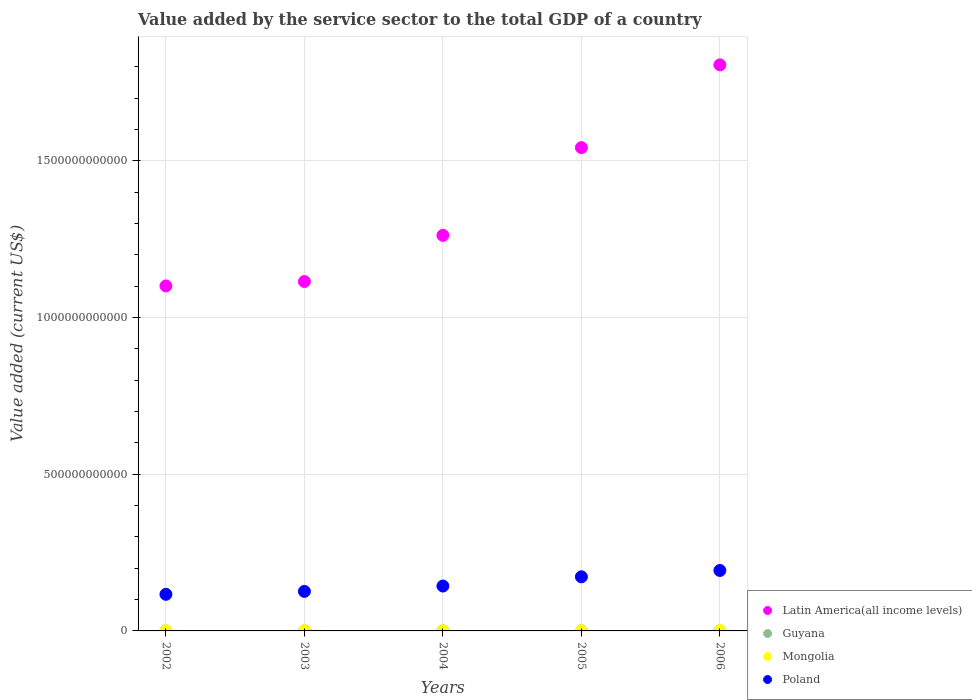Is the number of dotlines equal to the number of legend labels?
Offer a terse response. Yes. What is the value added by the service sector to the total GDP in Guyana in 2005?
Your answer should be compact. 3.13e+08. Across all years, what is the maximum value added by the service sector to the total GDP in Poland?
Provide a short and direct response. 1.93e+11. Across all years, what is the minimum value added by the service sector to the total GDP in Mongolia?
Ensure brevity in your answer.  6.51e+08. In which year was the value added by the service sector to the total GDP in Guyana maximum?
Keep it short and to the point. 2006. In which year was the value added by the service sector to the total GDP in Latin America(all income levels) minimum?
Your answer should be very brief. 2002. What is the total value added by the service sector to the total GDP in Guyana in the graph?
Offer a terse response. 1.71e+09. What is the difference between the value added by the service sector to the total GDP in Guyana in 2003 and that in 2005?
Provide a succinct answer. -4.98e+07. What is the difference between the value added by the service sector to the total GDP in Mongolia in 2006 and the value added by the service sector to the total GDP in Guyana in 2003?
Ensure brevity in your answer.  8.84e+08. What is the average value added by the service sector to the total GDP in Mongolia per year?
Ensure brevity in your answer.  8.53e+08. In the year 2002, what is the difference between the value added by the service sector to the total GDP in Guyana and value added by the service sector to the total GDP in Latin America(all income levels)?
Provide a short and direct response. -1.10e+12. What is the ratio of the value added by the service sector to the total GDP in Latin America(all income levels) in 2004 to that in 2005?
Provide a succinct answer. 0.82. Is the value added by the service sector to the total GDP in Poland in 2002 less than that in 2006?
Offer a very short reply. Yes. Is the difference between the value added by the service sector to the total GDP in Guyana in 2003 and 2006 greater than the difference between the value added by the service sector to the total GDP in Latin America(all income levels) in 2003 and 2006?
Your response must be concise. Yes. What is the difference between the highest and the second highest value added by the service sector to the total GDP in Latin America(all income levels)?
Give a very brief answer. 2.64e+11. What is the difference between the highest and the lowest value added by the service sector to the total GDP in Guyana?
Provide a succinct answer. 3.55e+08. Is it the case that in every year, the sum of the value added by the service sector to the total GDP in Mongolia and value added by the service sector to the total GDP in Guyana  is greater than the sum of value added by the service sector to the total GDP in Latin America(all income levels) and value added by the service sector to the total GDP in Poland?
Offer a very short reply. No. Is it the case that in every year, the sum of the value added by the service sector to the total GDP in Mongolia and value added by the service sector to the total GDP in Poland  is greater than the value added by the service sector to the total GDP in Latin America(all income levels)?
Keep it short and to the point. No. Does the value added by the service sector to the total GDP in Guyana monotonically increase over the years?
Provide a short and direct response. Yes. Is the value added by the service sector to the total GDP in Guyana strictly greater than the value added by the service sector to the total GDP in Mongolia over the years?
Give a very brief answer. No. How many years are there in the graph?
Keep it short and to the point. 5. What is the difference between two consecutive major ticks on the Y-axis?
Your response must be concise. 5.00e+11. Does the graph contain any zero values?
Make the answer very short. No. Where does the legend appear in the graph?
Your answer should be very brief. Bottom right. How many legend labels are there?
Offer a very short reply. 4. What is the title of the graph?
Keep it short and to the point. Value added by the service sector to the total GDP of a country. What is the label or title of the X-axis?
Provide a succinct answer. Years. What is the label or title of the Y-axis?
Your response must be concise. Value added (current US$). What is the Value added (current US$) of Latin America(all income levels) in 2002?
Your answer should be very brief. 1.10e+12. What is the Value added (current US$) in Guyana in 2002?
Provide a succinct answer. 2.51e+08. What is the Value added (current US$) in Mongolia in 2002?
Your response must be concise. 6.51e+08. What is the Value added (current US$) of Poland in 2002?
Provide a succinct answer. 1.17e+11. What is the Value added (current US$) of Latin America(all income levels) in 2003?
Provide a succinct answer. 1.11e+12. What is the Value added (current US$) in Guyana in 2003?
Make the answer very short. 2.63e+08. What is the Value added (current US$) of Mongolia in 2003?
Offer a very short reply. 7.20e+08. What is the Value added (current US$) of Poland in 2003?
Provide a succinct answer. 1.26e+11. What is the Value added (current US$) in Latin America(all income levels) in 2004?
Offer a terse response. 1.26e+12. What is the Value added (current US$) in Guyana in 2004?
Make the answer very short. 2.75e+08. What is the Value added (current US$) of Mongolia in 2004?
Offer a very short reply. 8.02e+08. What is the Value added (current US$) in Poland in 2004?
Make the answer very short. 1.43e+11. What is the Value added (current US$) of Latin America(all income levels) in 2005?
Your answer should be very brief. 1.54e+12. What is the Value added (current US$) of Guyana in 2005?
Keep it short and to the point. 3.13e+08. What is the Value added (current US$) in Mongolia in 2005?
Provide a short and direct response. 9.45e+08. What is the Value added (current US$) in Poland in 2005?
Your response must be concise. 1.73e+11. What is the Value added (current US$) in Latin America(all income levels) in 2006?
Make the answer very short. 1.81e+12. What is the Value added (current US$) of Guyana in 2006?
Ensure brevity in your answer.  6.05e+08. What is the Value added (current US$) in Mongolia in 2006?
Give a very brief answer. 1.15e+09. What is the Value added (current US$) of Poland in 2006?
Your response must be concise. 1.93e+11. Across all years, what is the maximum Value added (current US$) in Latin America(all income levels)?
Provide a succinct answer. 1.81e+12. Across all years, what is the maximum Value added (current US$) of Guyana?
Your answer should be compact. 6.05e+08. Across all years, what is the maximum Value added (current US$) in Mongolia?
Offer a very short reply. 1.15e+09. Across all years, what is the maximum Value added (current US$) in Poland?
Provide a short and direct response. 1.93e+11. Across all years, what is the minimum Value added (current US$) of Latin America(all income levels)?
Offer a very short reply. 1.10e+12. Across all years, what is the minimum Value added (current US$) in Guyana?
Offer a terse response. 2.51e+08. Across all years, what is the minimum Value added (current US$) in Mongolia?
Give a very brief answer. 6.51e+08. Across all years, what is the minimum Value added (current US$) of Poland?
Provide a short and direct response. 1.17e+11. What is the total Value added (current US$) of Latin America(all income levels) in the graph?
Provide a short and direct response. 6.83e+12. What is the total Value added (current US$) in Guyana in the graph?
Make the answer very short. 1.71e+09. What is the total Value added (current US$) of Mongolia in the graph?
Your answer should be very brief. 4.26e+09. What is the total Value added (current US$) in Poland in the graph?
Make the answer very short. 7.52e+11. What is the difference between the Value added (current US$) of Latin America(all income levels) in 2002 and that in 2003?
Give a very brief answer. -1.41e+1. What is the difference between the Value added (current US$) in Guyana in 2002 and that in 2003?
Give a very brief answer. -1.23e+07. What is the difference between the Value added (current US$) in Mongolia in 2002 and that in 2003?
Provide a short and direct response. -6.96e+07. What is the difference between the Value added (current US$) of Poland in 2002 and that in 2003?
Your answer should be very brief. -9.34e+09. What is the difference between the Value added (current US$) in Latin America(all income levels) in 2002 and that in 2004?
Your answer should be very brief. -1.61e+11. What is the difference between the Value added (current US$) in Guyana in 2002 and that in 2004?
Keep it short and to the point. -2.39e+07. What is the difference between the Value added (current US$) of Mongolia in 2002 and that in 2004?
Provide a short and direct response. -1.51e+08. What is the difference between the Value added (current US$) in Poland in 2002 and that in 2004?
Ensure brevity in your answer.  -2.64e+1. What is the difference between the Value added (current US$) of Latin America(all income levels) in 2002 and that in 2005?
Provide a short and direct response. -4.41e+11. What is the difference between the Value added (current US$) of Guyana in 2002 and that in 2005?
Your response must be concise. -6.21e+07. What is the difference between the Value added (current US$) of Mongolia in 2002 and that in 2005?
Provide a short and direct response. -2.94e+08. What is the difference between the Value added (current US$) in Poland in 2002 and that in 2005?
Provide a succinct answer. -5.59e+1. What is the difference between the Value added (current US$) of Latin America(all income levels) in 2002 and that in 2006?
Provide a succinct answer. -7.05e+11. What is the difference between the Value added (current US$) of Guyana in 2002 and that in 2006?
Provide a succinct answer. -3.55e+08. What is the difference between the Value added (current US$) in Mongolia in 2002 and that in 2006?
Offer a very short reply. -4.96e+08. What is the difference between the Value added (current US$) in Poland in 2002 and that in 2006?
Provide a succinct answer. -7.61e+1. What is the difference between the Value added (current US$) of Latin America(all income levels) in 2003 and that in 2004?
Keep it short and to the point. -1.47e+11. What is the difference between the Value added (current US$) in Guyana in 2003 and that in 2004?
Offer a very short reply. -1.16e+07. What is the difference between the Value added (current US$) in Mongolia in 2003 and that in 2004?
Give a very brief answer. -8.12e+07. What is the difference between the Value added (current US$) of Poland in 2003 and that in 2004?
Make the answer very short. -1.71e+1. What is the difference between the Value added (current US$) in Latin America(all income levels) in 2003 and that in 2005?
Keep it short and to the point. -4.27e+11. What is the difference between the Value added (current US$) in Guyana in 2003 and that in 2005?
Keep it short and to the point. -4.98e+07. What is the difference between the Value added (current US$) of Mongolia in 2003 and that in 2005?
Offer a very short reply. -2.25e+08. What is the difference between the Value added (current US$) of Poland in 2003 and that in 2005?
Offer a terse response. -4.66e+1. What is the difference between the Value added (current US$) of Latin America(all income levels) in 2003 and that in 2006?
Your answer should be compact. -6.91e+11. What is the difference between the Value added (current US$) in Guyana in 2003 and that in 2006?
Provide a short and direct response. -3.42e+08. What is the difference between the Value added (current US$) in Mongolia in 2003 and that in 2006?
Offer a very short reply. -4.27e+08. What is the difference between the Value added (current US$) in Poland in 2003 and that in 2006?
Provide a succinct answer. -6.68e+1. What is the difference between the Value added (current US$) in Latin America(all income levels) in 2004 and that in 2005?
Ensure brevity in your answer.  -2.80e+11. What is the difference between the Value added (current US$) in Guyana in 2004 and that in 2005?
Your answer should be compact. -3.82e+07. What is the difference between the Value added (current US$) in Mongolia in 2004 and that in 2005?
Offer a very short reply. -1.44e+08. What is the difference between the Value added (current US$) of Poland in 2004 and that in 2005?
Give a very brief answer. -2.95e+1. What is the difference between the Value added (current US$) in Latin America(all income levels) in 2004 and that in 2006?
Keep it short and to the point. -5.44e+11. What is the difference between the Value added (current US$) of Guyana in 2004 and that in 2006?
Offer a terse response. -3.31e+08. What is the difference between the Value added (current US$) in Mongolia in 2004 and that in 2006?
Your answer should be compact. -3.46e+08. What is the difference between the Value added (current US$) of Poland in 2004 and that in 2006?
Your response must be concise. -4.97e+1. What is the difference between the Value added (current US$) in Latin America(all income levels) in 2005 and that in 2006?
Offer a very short reply. -2.64e+11. What is the difference between the Value added (current US$) in Guyana in 2005 and that in 2006?
Provide a succinct answer. -2.92e+08. What is the difference between the Value added (current US$) of Mongolia in 2005 and that in 2006?
Ensure brevity in your answer.  -2.02e+08. What is the difference between the Value added (current US$) in Poland in 2005 and that in 2006?
Make the answer very short. -2.02e+1. What is the difference between the Value added (current US$) in Latin America(all income levels) in 2002 and the Value added (current US$) in Guyana in 2003?
Provide a succinct answer. 1.10e+12. What is the difference between the Value added (current US$) in Latin America(all income levels) in 2002 and the Value added (current US$) in Mongolia in 2003?
Keep it short and to the point. 1.10e+12. What is the difference between the Value added (current US$) of Latin America(all income levels) in 2002 and the Value added (current US$) of Poland in 2003?
Provide a short and direct response. 9.74e+11. What is the difference between the Value added (current US$) of Guyana in 2002 and the Value added (current US$) of Mongolia in 2003?
Offer a terse response. -4.70e+08. What is the difference between the Value added (current US$) in Guyana in 2002 and the Value added (current US$) in Poland in 2003?
Keep it short and to the point. -1.26e+11. What is the difference between the Value added (current US$) in Mongolia in 2002 and the Value added (current US$) in Poland in 2003?
Keep it short and to the point. -1.25e+11. What is the difference between the Value added (current US$) of Latin America(all income levels) in 2002 and the Value added (current US$) of Guyana in 2004?
Keep it short and to the point. 1.10e+12. What is the difference between the Value added (current US$) in Latin America(all income levels) in 2002 and the Value added (current US$) in Mongolia in 2004?
Provide a succinct answer. 1.10e+12. What is the difference between the Value added (current US$) in Latin America(all income levels) in 2002 and the Value added (current US$) in Poland in 2004?
Provide a succinct answer. 9.57e+11. What is the difference between the Value added (current US$) in Guyana in 2002 and the Value added (current US$) in Mongolia in 2004?
Offer a very short reply. -5.51e+08. What is the difference between the Value added (current US$) of Guyana in 2002 and the Value added (current US$) of Poland in 2004?
Keep it short and to the point. -1.43e+11. What is the difference between the Value added (current US$) of Mongolia in 2002 and the Value added (current US$) of Poland in 2004?
Your answer should be very brief. -1.43e+11. What is the difference between the Value added (current US$) of Latin America(all income levels) in 2002 and the Value added (current US$) of Guyana in 2005?
Give a very brief answer. 1.10e+12. What is the difference between the Value added (current US$) of Latin America(all income levels) in 2002 and the Value added (current US$) of Mongolia in 2005?
Ensure brevity in your answer.  1.10e+12. What is the difference between the Value added (current US$) in Latin America(all income levels) in 2002 and the Value added (current US$) in Poland in 2005?
Give a very brief answer. 9.28e+11. What is the difference between the Value added (current US$) in Guyana in 2002 and the Value added (current US$) in Mongolia in 2005?
Give a very brief answer. -6.94e+08. What is the difference between the Value added (current US$) of Guyana in 2002 and the Value added (current US$) of Poland in 2005?
Give a very brief answer. -1.72e+11. What is the difference between the Value added (current US$) in Mongolia in 2002 and the Value added (current US$) in Poland in 2005?
Your answer should be compact. -1.72e+11. What is the difference between the Value added (current US$) of Latin America(all income levels) in 2002 and the Value added (current US$) of Guyana in 2006?
Your answer should be compact. 1.10e+12. What is the difference between the Value added (current US$) of Latin America(all income levels) in 2002 and the Value added (current US$) of Mongolia in 2006?
Your response must be concise. 1.10e+12. What is the difference between the Value added (current US$) in Latin America(all income levels) in 2002 and the Value added (current US$) in Poland in 2006?
Your response must be concise. 9.08e+11. What is the difference between the Value added (current US$) of Guyana in 2002 and the Value added (current US$) of Mongolia in 2006?
Your response must be concise. -8.96e+08. What is the difference between the Value added (current US$) of Guyana in 2002 and the Value added (current US$) of Poland in 2006?
Make the answer very short. -1.93e+11. What is the difference between the Value added (current US$) in Mongolia in 2002 and the Value added (current US$) in Poland in 2006?
Your answer should be very brief. -1.92e+11. What is the difference between the Value added (current US$) of Latin America(all income levels) in 2003 and the Value added (current US$) of Guyana in 2004?
Your answer should be very brief. 1.11e+12. What is the difference between the Value added (current US$) of Latin America(all income levels) in 2003 and the Value added (current US$) of Mongolia in 2004?
Offer a very short reply. 1.11e+12. What is the difference between the Value added (current US$) in Latin America(all income levels) in 2003 and the Value added (current US$) in Poland in 2004?
Make the answer very short. 9.72e+11. What is the difference between the Value added (current US$) of Guyana in 2003 and the Value added (current US$) of Mongolia in 2004?
Offer a very short reply. -5.38e+08. What is the difference between the Value added (current US$) of Guyana in 2003 and the Value added (current US$) of Poland in 2004?
Keep it short and to the point. -1.43e+11. What is the difference between the Value added (current US$) of Mongolia in 2003 and the Value added (current US$) of Poland in 2004?
Provide a short and direct response. -1.42e+11. What is the difference between the Value added (current US$) of Latin America(all income levels) in 2003 and the Value added (current US$) of Guyana in 2005?
Your response must be concise. 1.11e+12. What is the difference between the Value added (current US$) of Latin America(all income levels) in 2003 and the Value added (current US$) of Mongolia in 2005?
Offer a terse response. 1.11e+12. What is the difference between the Value added (current US$) in Latin America(all income levels) in 2003 and the Value added (current US$) in Poland in 2005?
Provide a short and direct response. 9.42e+11. What is the difference between the Value added (current US$) in Guyana in 2003 and the Value added (current US$) in Mongolia in 2005?
Ensure brevity in your answer.  -6.82e+08. What is the difference between the Value added (current US$) in Guyana in 2003 and the Value added (current US$) in Poland in 2005?
Keep it short and to the point. -1.72e+11. What is the difference between the Value added (current US$) in Mongolia in 2003 and the Value added (current US$) in Poland in 2005?
Your answer should be very brief. -1.72e+11. What is the difference between the Value added (current US$) in Latin America(all income levels) in 2003 and the Value added (current US$) in Guyana in 2006?
Your answer should be very brief. 1.11e+12. What is the difference between the Value added (current US$) in Latin America(all income levels) in 2003 and the Value added (current US$) in Mongolia in 2006?
Your answer should be very brief. 1.11e+12. What is the difference between the Value added (current US$) of Latin America(all income levels) in 2003 and the Value added (current US$) of Poland in 2006?
Your answer should be very brief. 9.22e+11. What is the difference between the Value added (current US$) in Guyana in 2003 and the Value added (current US$) in Mongolia in 2006?
Your response must be concise. -8.84e+08. What is the difference between the Value added (current US$) of Guyana in 2003 and the Value added (current US$) of Poland in 2006?
Your response must be concise. -1.93e+11. What is the difference between the Value added (current US$) in Mongolia in 2003 and the Value added (current US$) in Poland in 2006?
Your answer should be very brief. -1.92e+11. What is the difference between the Value added (current US$) of Latin America(all income levels) in 2004 and the Value added (current US$) of Guyana in 2005?
Your answer should be very brief. 1.26e+12. What is the difference between the Value added (current US$) of Latin America(all income levels) in 2004 and the Value added (current US$) of Mongolia in 2005?
Ensure brevity in your answer.  1.26e+12. What is the difference between the Value added (current US$) in Latin America(all income levels) in 2004 and the Value added (current US$) in Poland in 2005?
Your answer should be very brief. 1.09e+12. What is the difference between the Value added (current US$) in Guyana in 2004 and the Value added (current US$) in Mongolia in 2005?
Keep it short and to the point. -6.71e+08. What is the difference between the Value added (current US$) of Guyana in 2004 and the Value added (current US$) of Poland in 2005?
Your answer should be very brief. -1.72e+11. What is the difference between the Value added (current US$) in Mongolia in 2004 and the Value added (current US$) in Poland in 2005?
Give a very brief answer. -1.72e+11. What is the difference between the Value added (current US$) of Latin America(all income levels) in 2004 and the Value added (current US$) of Guyana in 2006?
Offer a very short reply. 1.26e+12. What is the difference between the Value added (current US$) of Latin America(all income levels) in 2004 and the Value added (current US$) of Mongolia in 2006?
Your answer should be very brief. 1.26e+12. What is the difference between the Value added (current US$) in Latin America(all income levels) in 2004 and the Value added (current US$) in Poland in 2006?
Your answer should be very brief. 1.07e+12. What is the difference between the Value added (current US$) in Guyana in 2004 and the Value added (current US$) in Mongolia in 2006?
Your answer should be compact. -8.73e+08. What is the difference between the Value added (current US$) of Guyana in 2004 and the Value added (current US$) of Poland in 2006?
Provide a succinct answer. -1.93e+11. What is the difference between the Value added (current US$) of Mongolia in 2004 and the Value added (current US$) of Poland in 2006?
Keep it short and to the point. -1.92e+11. What is the difference between the Value added (current US$) of Latin America(all income levels) in 2005 and the Value added (current US$) of Guyana in 2006?
Your answer should be compact. 1.54e+12. What is the difference between the Value added (current US$) of Latin America(all income levels) in 2005 and the Value added (current US$) of Mongolia in 2006?
Offer a terse response. 1.54e+12. What is the difference between the Value added (current US$) in Latin America(all income levels) in 2005 and the Value added (current US$) in Poland in 2006?
Provide a succinct answer. 1.35e+12. What is the difference between the Value added (current US$) in Guyana in 2005 and the Value added (current US$) in Mongolia in 2006?
Provide a short and direct response. -8.34e+08. What is the difference between the Value added (current US$) of Guyana in 2005 and the Value added (current US$) of Poland in 2006?
Provide a succinct answer. -1.93e+11. What is the difference between the Value added (current US$) in Mongolia in 2005 and the Value added (current US$) in Poland in 2006?
Your response must be concise. -1.92e+11. What is the average Value added (current US$) in Latin America(all income levels) per year?
Your response must be concise. 1.37e+12. What is the average Value added (current US$) of Guyana per year?
Offer a very short reply. 3.41e+08. What is the average Value added (current US$) in Mongolia per year?
Offer a very short reply. 8.53e+08. What is the average Value added (current US$) of Poland per year?
Offer a terse response. 1.50e+11. In the year 2002, what is the difference between the Value added (current US$) of Latin America(all income levels) and Value added (current US$) of Guyana?
Your response must be concise. 1.10e+12. In the year 2002, what is the difference between the Value added (current US$) of Latin America(all income levels) and Value added (current US$) of Mongolia?
Give a very brief answer. 1.10e+12. In the year 2002, what is the difference between the Value added (current US$) in Latin America(all income levels) and Value added (current US$) in Poland?
Your answer should be compact. 9.84e+11. In the year 2002, what is the difference between the Value added (current US$) of Guyana and Value added (current US$) of Mongolia?
Give a very brief answer. -4.00e+08. In the year 2002, what is the difference between the Value added (current US$) in Guyana and Value added (current US$) in Poland?
Keep it short and to the point. -1.17e+11. In the year 2002, what is the difference between the Value added (current US$) of Mongolia and Value added (current US$) of Poland?
Provide a short and direct response. -1.16e+11. In the year 2003, what is the difference between the Value added (current US$) in Latin America(all income levels) and Value added (current US$) in Guyana?
Provide a short and direct response. 1.11e+12. In the year 2003, what is the difference between the Value added (current US$) of Latin America(all income levels) and Value added (current US$) of Mongolia?
Keep it short and to the point. 1.11e+12. In the year 2003, what is the difference between the Value added (current US$) of Latin America(all income levels) and Value added (current US$) of Poland?
Your response must be concise. 9.89e+11. In the year 2003, what is the difference between the Value added (current US$) of Guyana and Value added (current US$) of Mongolia?
Make the answer very short. -4.57e+08. In the year 2003, what is the difference between the Value added (current US$) of Guyana and Value added (current US$) of Poland?
Provide a short and direct response. -1.26e+11. In the year 2003, what is the difference between the Value added (current US$) in Mongolia and Value added (current US$) in Poland?
Provide a short and direct response. -1.25e+11. In the year 2004, what is the difference between the Value added (current US$) in Latin America(all income levels) and Value added (current US$) in Guyana?
Offer a terse response. 1.26e+12. In the year 2004, what is the difference between the Value added (current US$) of Latin America(all income levels) and Value added (current US$) of Mongolia?
Keep it short and to the point. 1.26e+12. In the year 2004, what is the difference between the Value added (current US$) in Latin America(all income levels) and Value added (current US$) in Poland?
Your answer should be very brief. 1.12e+12. In the year 2004, what is the difference between the Value added (current US$) in Guyana and Value added (current US$) in Mongolia?
Offer a terse response. -5.27e+08. In the year 2004, what is the difference between the Value added (current US$) of Guyana and Value added (current US$) of Poland?
Make the answer very short. -1.43e+11. In the year 2004, what is the difference between the Value added (current US$) in Mongolia and Value added (current US$) in Poland?
Offer a terse response. -1.42e+11. In the year 2005, what is the difference between the Value added (current US$) in Latin America(all income levels) and Value added (current US$) in Guyana?
Make the answer very short. 1.54e+12. In the year 2005, what is the difference between the Value added (current US$) in Latin America(all income levels) and Value added (current US$) in Mongolia?
Keep it short and to the point. 1.54e+12. In the year 2005, what is the difference between the Value added (current US$) of Latin America(all income levels) and Value added (current US$) of Poland?
Ensure brevity in your answer.  1.37e+12. In the year 2005, what is the difference between the Value added (current US$) in Guyana and Value added (current US$) in Mongolia?
Your answer should be very brief. -6.32e+08. In the year 2005, what is the difference between the Value added (current US$) of Guyana and Value added (current US$) of Poland?
Your answer should be very brief. -1.72e+11. In the year 2005, what is the difference between the Value added (current US$) of Mongolia and Value added (current US$) of Poland?
Make the answer very short. -1.72e+11. In the year 2006, what is the difference between the Value added (current US$) in Latin America(all income levels) and Value added (current US$) in Guyana?
Your response must be concise. 1.81e+12. In the year 2006, what is the difference between the Value added (current US$) of Latin America(all income levels) and Value added (current US$) of Mongolia?
Your response must be concise. 1.80e+12. In the year 2006, what is the difference between the Value added (current US$) in Latin America(all income levels) and Value added (current US$) in Poland?
Give a very brief answer. 1.61e+12. In the year 2006, what is the difference between the Value added (current US$) in Guyana and Value added (current US$) in Mongolia?
Give a very brief answer. -5.42e+08. In the year 2006, what is the difference between the Value added (current US$) of Guyana and Value added (current US$) of Poland?
Give a very brief answer. -1.92e+11. In the year 2006, what is the difference between the Value added (current US$) in Mongolia and Value added (current US$) in Poland?
Provide a succinct answer. -1.92e+11. What is the ratio of the Value added (current US$) in Latin America(all income levels) in 2002 to that in 2003?
Provide a short and direct response. 0.99. What is the ratio of the Value added (current US$) in Guyana in 2002 to that in 2003?
Keep it short and to the point. 0.95. What is the ratio of the Value added (current US$) of Mongolia in 2002 to that in 2003?
Give a very brief answer. 0.9. What is the ratio of the Value added (current US$) of Poland in 2002 to that in 2003?
Provide a short and direct response. 0.93. What is the ratio of the Value added (current US$) in Latin America(all income levels) in 2002 to that in 2004?
Ensure brevity in your answer.  0.87. What is the ratio of the Value added (current US$) in Guyana in 2002 to that in 2004?
Your answer should be very brief. 0.91. What is the ratio of the Value added (current US$) of Mongolia in 2002 to that in 2004?
Your response must be concise. 0.81. What is the ratio of the Value added (current US$) of Poland in 2002 to that in 2004?
Your answer should be very brief. 0.82. What is the ratio of the Value added (current US$) in Latin America(all income levels) in 2002 to that in 2005?
Ensure brevity in your answer.  0.71. What is the ratio of the Value added (current US$) in Guyana in 2002 to that in 2005?
Your response must be concise. 0.8. What is the ratio of the Value added (current US$) in Mongolia in 2002 to that in 2005?
Your answer should be very brief. 0.69. What is the ratio of the Value added (current US$) in Poland in 2002 to that in 2005?
Give a very brief answer. 0.68. What is the ratio of the Value added (current US$) of Latin America(all income levels) in 2002 to that in 2006?
Your answer should be compact. 0.61. What is the ratio of the Value added (current US$) in Guyana in 2002 to that in 2006?
Give a very brief answer. 0.41. What is the ratio of the Value added (current US$) in Mongolia in 2002 to that in 2006?
Give a very brief answer. 0.57. What is the ratio of the Value added (current US$) of Poland in 2002 to that in 2006?
Your answer should be compact. 0.61. What is the ratio of the Value added (current US$) of Latin America(all income levels) in 2003 to that in 2004?
Offer a very short reply. 0.88. What is the ratio of the Value added (current US$) in Guyana in 2003 to that in 2004?
Make the answer very short. 0.96. What is the ratio of the Value added (current US$) in Mongolia in 2003 to that in 2004?
Provide a succinct answer. 0.9. What is the ratio of the Value added (current US$) in Poland in 2003 to that in 2004?
Offer a very short reply. 0.88. What is the ratio of the Value added (current US$) in Latin America(all income levels) in 2003 to that in 2005?
Your answer should be very brief. 0.72. What is the ratio of the Value added (current US$) in Guyana in 2003 to that in 2005?
Offer a very short reply. 0.84. What is the ratio of the Value added (current US$) in Mongolia in 2003 to that in 2005?
Keep it short and to the point. 0.76. What is the ratio of the Value added (current US$) of Poland in 2003 to that in 2005?
Provide a short and direct response. 0.73. What is the ratio of the Value added (current US$) of Latin America(all income levels) in 2003 to that in 2006?
Provide a short and direct response. 0.62. What is the ratio of the Value added (current US$) of Guyana in 2003 to that in 2006?
Offer a terse response. 0.43. What is the ratio of the Value added (current US$) of Mongolia in 2003 to that in 2006?
Your answer should be very brief. 0.63. What is the ratio of the Value added (current US$) of Poland in 2003 to that in 2006?
Your response must be concise. 0.65. What is the ratio of the Value added (current US$) in Latin America(all income levels) in 2004 to that in 2005?
Give a very brief answer. 0.82. What is the ratio of the Value added (current US$) of Guyana in 2004 to that in 2005?
Your answer should be very brief. 0.88. What is the ratio of the Value added (current US$) in Mongolia in 2004 to that in 2005?
Give a very brief answer. 0.85. What is the ratio of the Value added (current US$) in Poland in 2004 to that in 2005?
Provide a short and direct response. 0.83. What is the ratio of the Value added (current US$) of Latin America(all income levels) in 2004 to that in 2006?
Offer a very short reply. 0.7. What is the ratio of the Value added (current US$) in Guyana in 2004 to that in 2006?
Make the answer very short. 0.45. What is the ratio of the Value added (current US$) in Mongolia in 2004 to that in 2006?
Make the answer very short. 0.7. What is the ratio of the Value added (current US$) of Poland in 2004 to that in 2006?
Your response must be concise. 0.74. What is the ratio of the Value added (current US$) in Latin America(all income levels) in 2005 to that in 2006?
Make the answer very short. 0.85. What is the ratio of the Value added (current US$) in Guyana in 2005 to that in 2006?
Make the answer very short. 0.52. What is the ratio of the Value added (current US$) of Mongolia in 2005 to that in 2006?
Offer a terse response. 0.82. What is the ratio of the Value added (current US$) in Poland in 2005 to that in 2006?
Your answer should be very brief. 0.9. What is the difference between the highest and the second highest Value added (current US$) of Latin America(all income levels)?
Your answer should be compact. 2.64e+11. What is the difference between the highest and the second highest Value added (current US$) in Guyana?
Your answer should be compact. 2.92e+08. What is the difference between the highest and the second highest Value added (current US$) in Mongolia?
Provide a short and direct response. 2.02e+08. What is the difference between the highest and the second highest Value added (current US$) in Poland?
Your answer should be very brief. 2.02e+1. What is the difference between the highest and the lowest Value added (current US$) of Latin America(all income levels)?
Your answer should be compact. 7.05e+11. What is the difference between the highest and the lowest Value added (current US$) of Guyana?
Offer a very short reply. 3.55e+08. What is the difference between the highest and the lowest Value added (current US$) of Mongolia?
Your response must be concise. 4.96e+08. What is the difference between the highest and the lowest Value added (current US$) in Poland?
Your answer should be compact. 7.61e+1. 